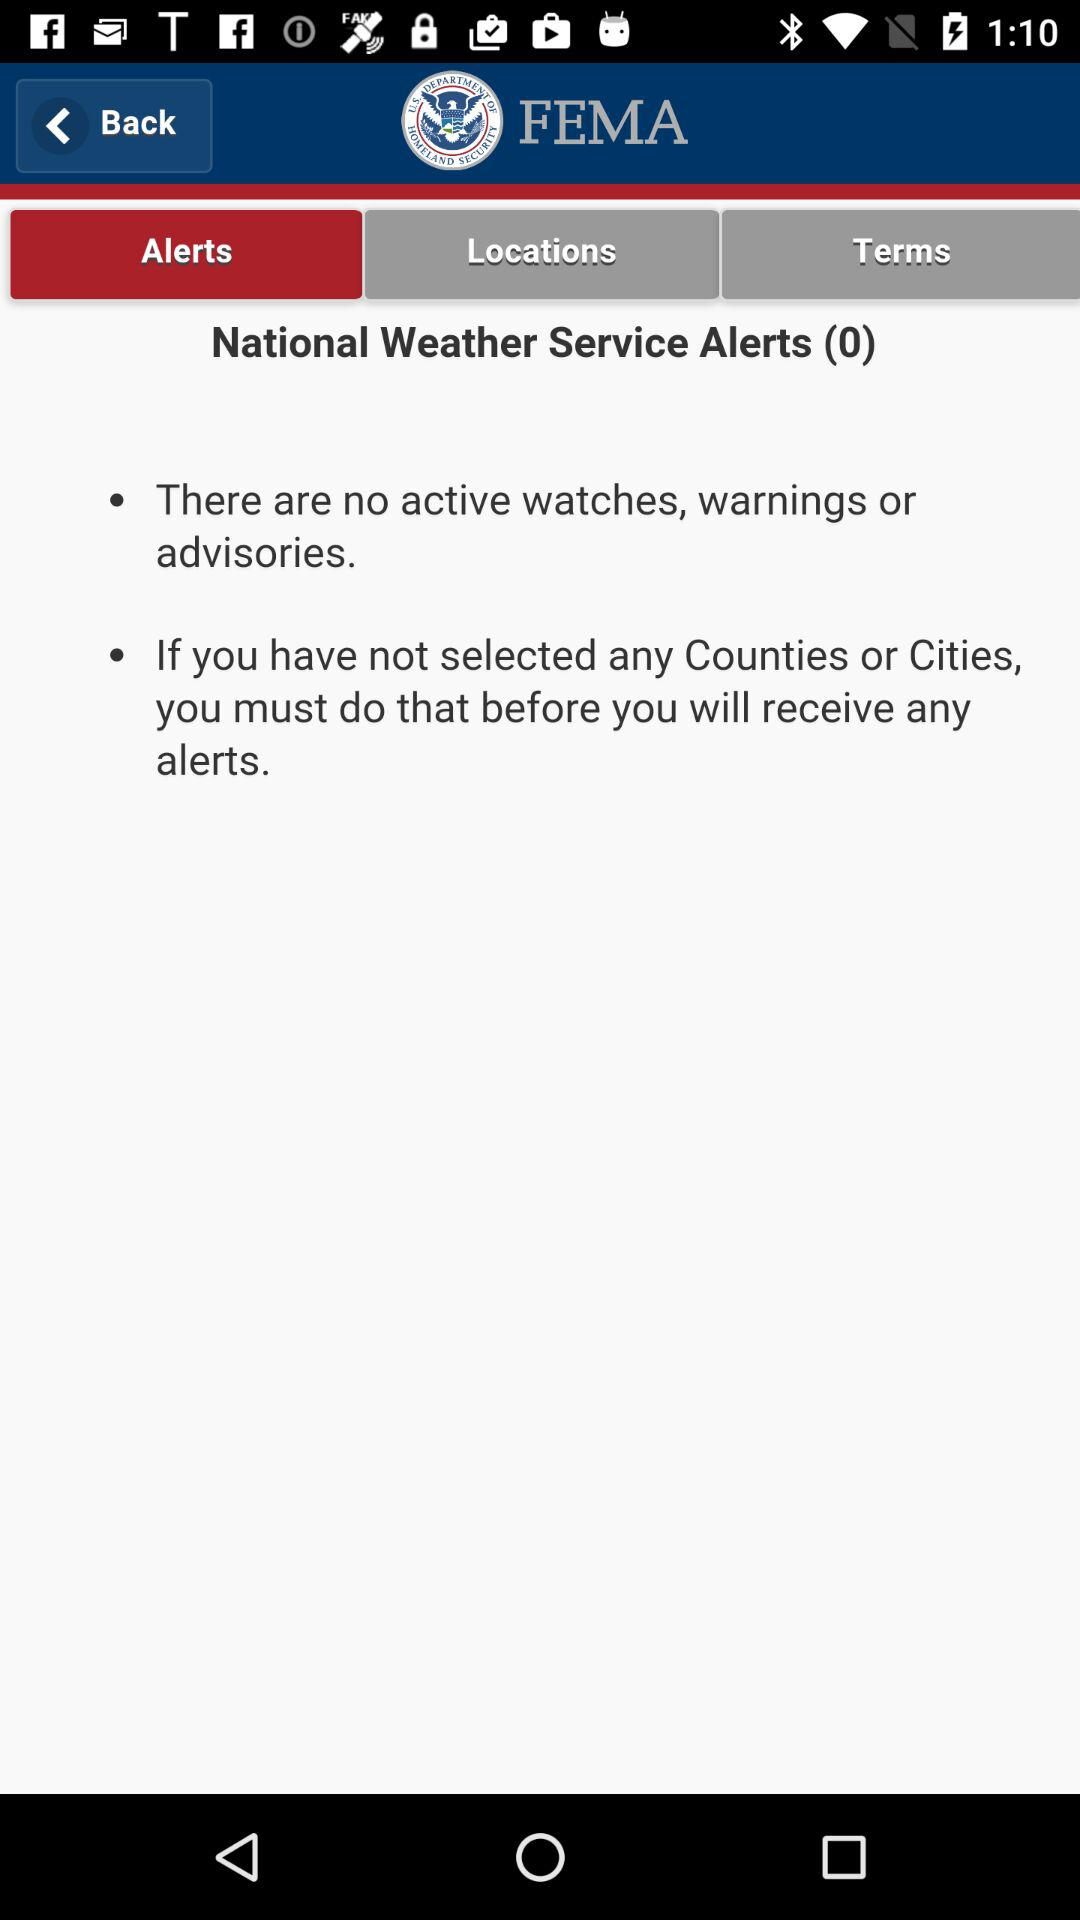What is the name of the application? The name of the application is "FEMA". 